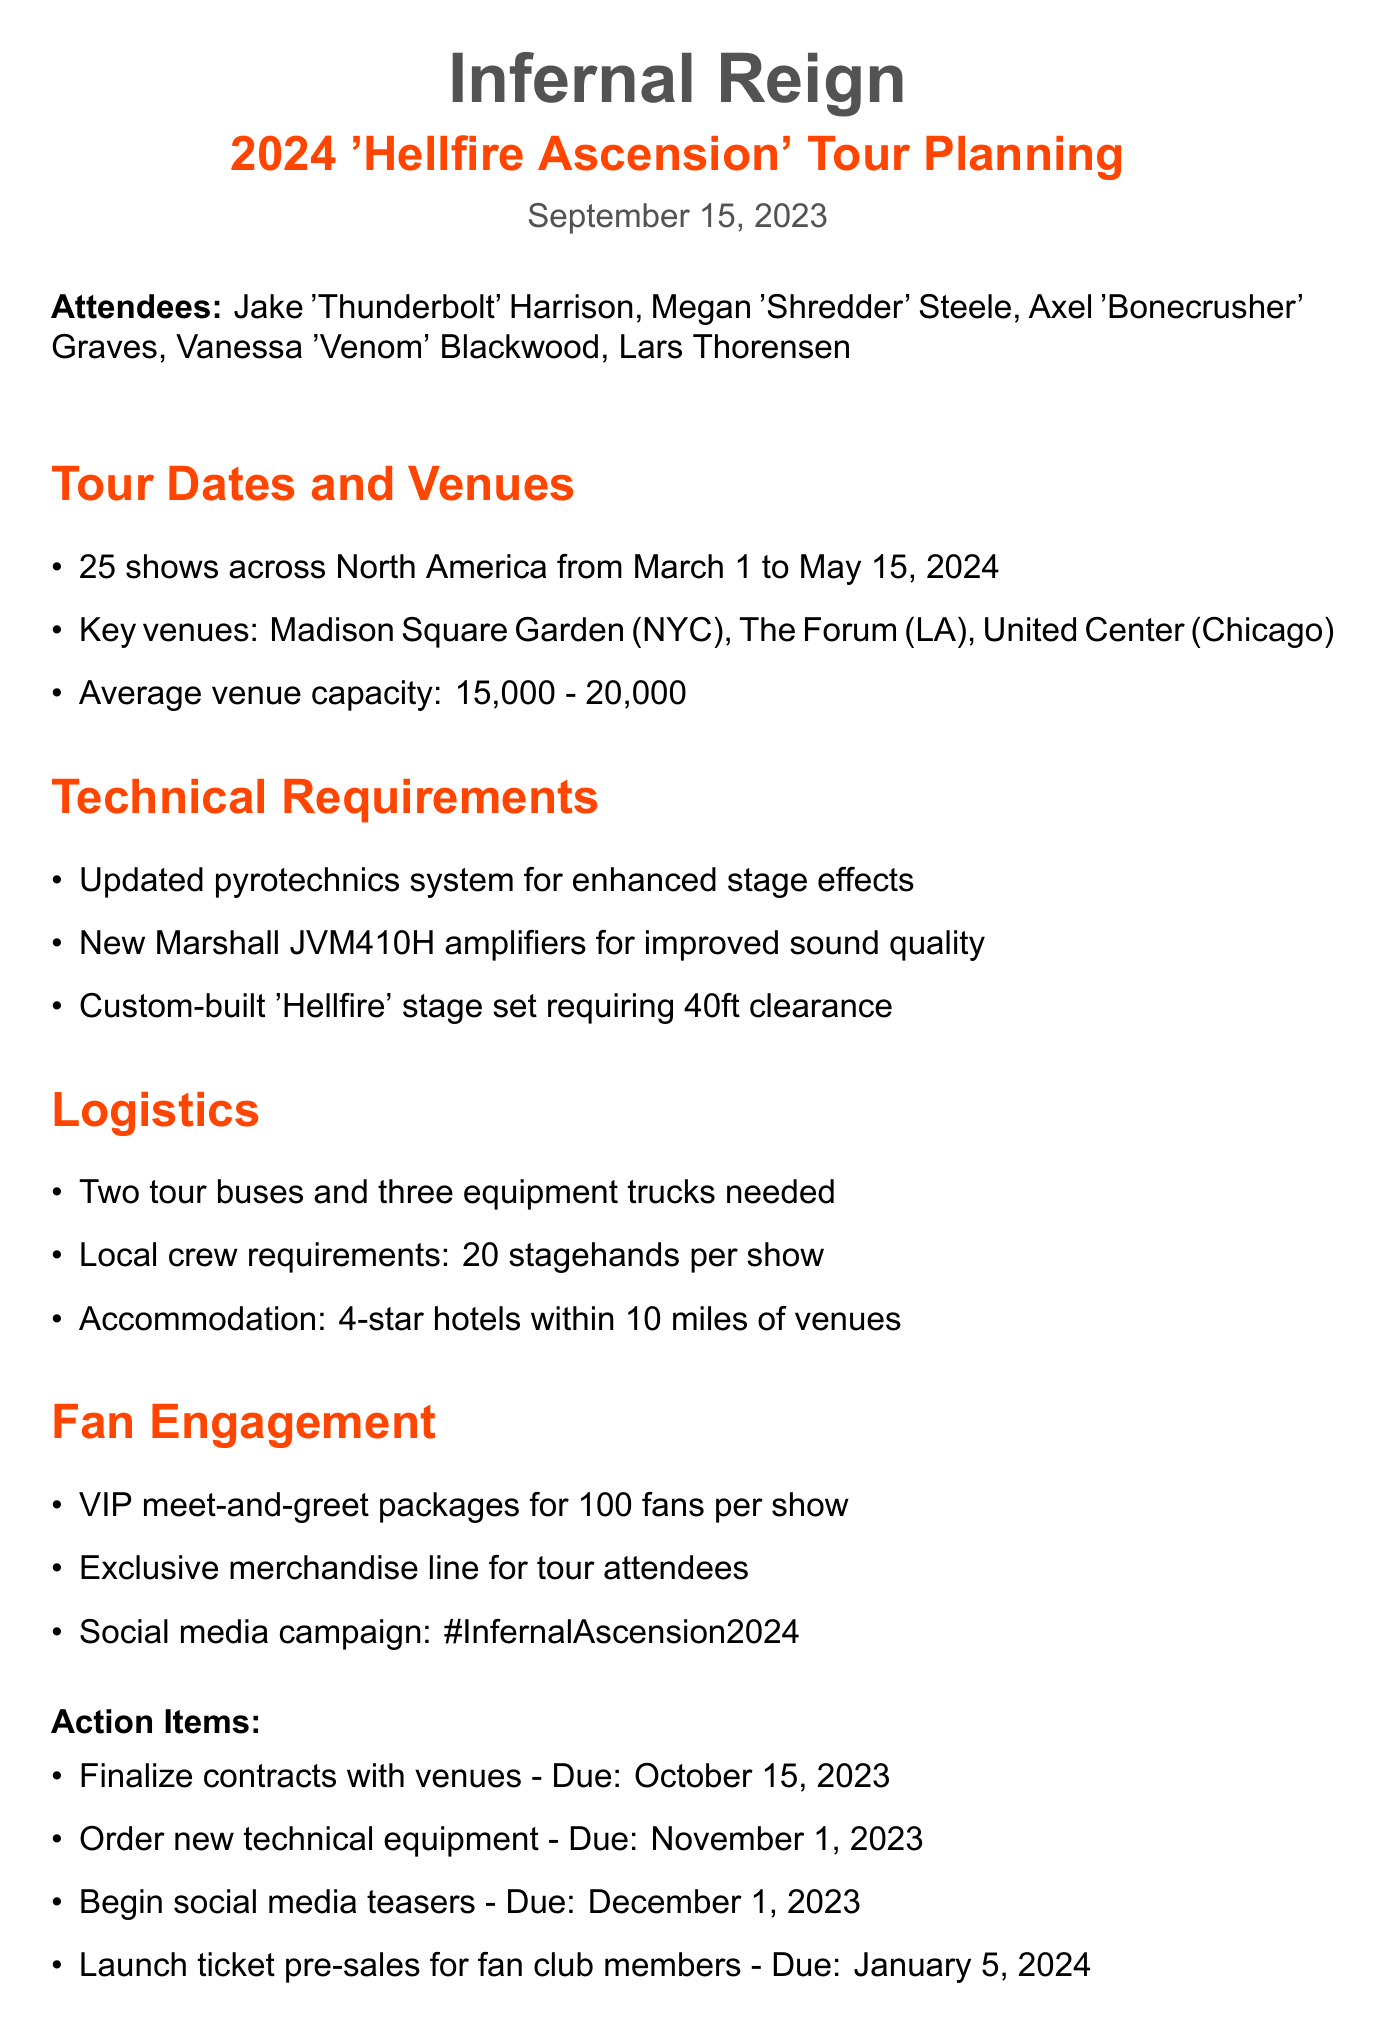What is the name of the band? The name of the band is mentioned at the top of the document, which is Infernal Reign.
Answer: Infernal Reign When does the tour start? The start date of the tour is specified under the Tour Dates and Venues section of the document as March 1, 2024.
Answer: March 1, 2024 How many shows will be held during the tour? The total number of shows is listed in the Tour Dates and Venues section as 25 shows.
Answer: 25 shows What is the average capacity of the venues? The average venue capacity is stated in the document as ranging from 15,000 to 20,000.
Answer: 15,000 - 20,000 What are the local crew requirements per show? The number of stagehands needed per show is provided in the Logistics section of the document as 20 stagehands.
Answer: 20 stagehands What is the due date for finalizing contracts with venues? The due date for this action item is listed in the Action Items section of the document as October 15, 2023.
Answer: October 15, 2023 What type of amplifiers will be used for the tour? The specific amplifiers mentioned in the Technical Requirements are Marshall JVM410H amplifiers.
Answer: Marshall JVM410H How far should hotels be located from the venues? The accommodation requirement specifies that hotels should be within 10 miles of the venues.
Answer: 10 miles What is the social media campaign hashtag for this tour? The document lists the campaign hashtag under Fan Engagement as #InfernalAscension2024.
Answer: #InfernalAscension2024 